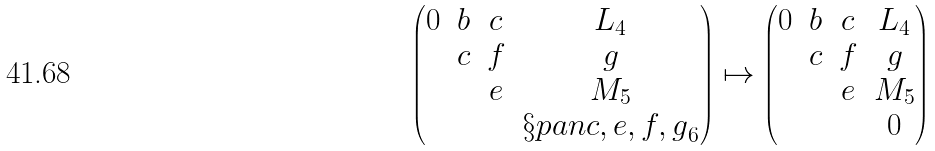<formula> <loc_0><loc_0><loc_500><loc_500>\begin{pmatrix} 0 & b & c & L _ { 4 } \\ & c & f & g \\ & & e & M _ { 5 } \\ & & & \S p a n { c , e , f , g } _ { 6 } \end{pmatrix} \mapsto \begin{pmatrix} 0 & b & c & L _ { 4 } \\ & c & f & g \\ & & e & M _ { 5 } \\ & & & 0 \end{pmatrix}</formula> 